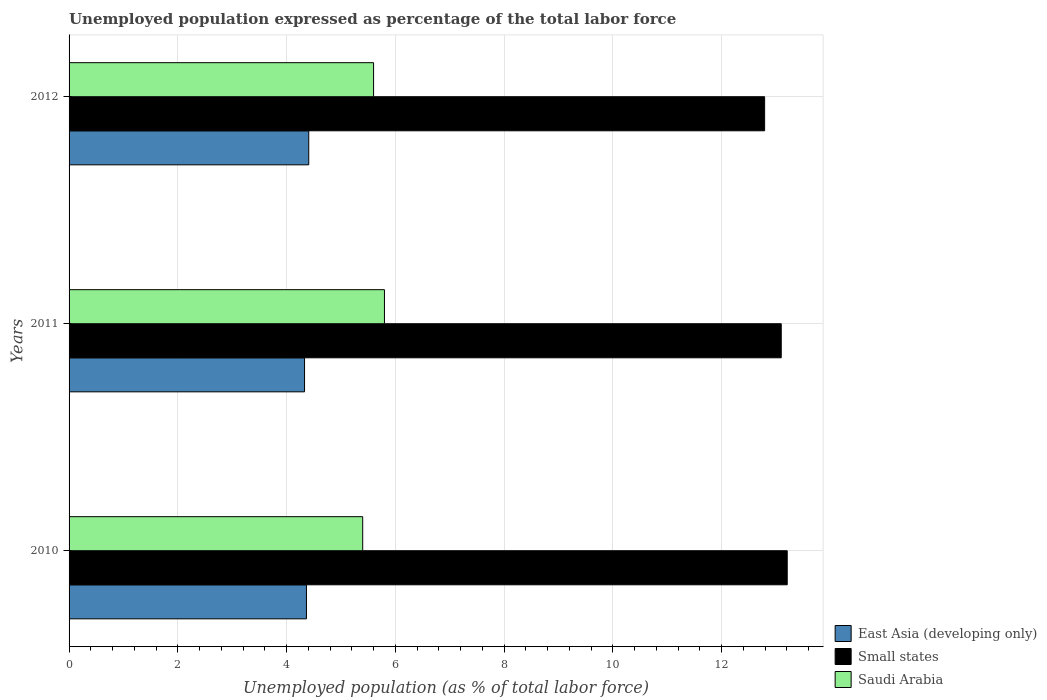How many different coloured bars are there?
Offer a terse response. 3. How many groups of bars are there?
Provide a short and direct response. 3. What is the label of the 2nd group of bars from the top?
Offer a very short reply. 2011. What is the unemployment in in Saudi Arabia in 2012?
Keep it short and to the point. 5.6. Across all years, what is the maximum unemployment in in Small states?
Make the answer very short. 13.21. Across all years, what is the minimum unemployment in in Small states?
Offer a very short reply. 12.79. In which year was the unemployment in in Saudi Arabia minimum?
Ensure brevity in your answer.  2010. What is the total unemployment in in Small states in the graph?
Offer a very short reply. 39.09. What is the difference between the unemployment in in Small states in 2010 and that in 2012?
Offer a terse response. 0.42. What is the difference between the unemployment in in East Asia (developing only) in 2010 and the unemployment in in Saudi Arabia in 2012?
Your response must be concise. -1.23. What is the average unemployment in in Saudi Arabia per year?
Offer a very short reply. 5.6. In the year 2012, what is the difference between the unemployment in in Small states and unemployment in in Saudi Arabia?
Your answer should be compact. 7.19. In how many years, is the unemployment in in East Asia (developing only) greater than 3.2 %?
Make the answer very short. 3. What is the ratio of the unemployment in in Saudi Arabia in 2010 to that in 2012?
Your answer should be very brief. 0.96. What is the difference between the highest and the second highest unemployment in in Small states?
Your response must be concise. 0.11. What is the difference between the highest and the lowest unemployment in in East Asia (developing only)?
Your answer should be very brief. 0.08. In how many years, is the unemployment in in Saudi Arabia greater than the average unemployment in in Saudi Arabia taken over all years?
Your answer should be compact. 1. Is the sum of the unemployment in in Saudi Arabia in 2010 and 2011 greater than the maximum unemployment in in Small states across all years?
Provide a succinct answer. No. What does the 1st bar from the top in 2010 represents?
Make the answer very short. Saudi Arabia. What does the 2nd bar from the bottom in 2011 represents?
Ensure brevity in your answer.  Small states. Is it the case that in every year, the sum of the unemployment in in Saudi Arabia and unemployment in in East Asia (developing only) is greater than the unemployment in in Small states?
Your answer should be compact. No. Are all the bars in the graph horizontal?
Offer a terse response. Yes. How many years are there in the graph?
Your response must be concise. 3. Are the values on the major ticks of X-axis written in scientific E-notation?
Your response must be concise. No. How many legend labels are there?
Ensure brevity in your answer.  3. How are the legend labels stacked?
Give a very brief answer. Vertical. What is the title of the graph?
Your response must be concise. Unemployed population expressed as percentage of the total labor force. Does "Low income" appear as one of the legend labels in the graph?
Offer a very short reply. No. What is the label or title of the X-axis?
Make the answer very short. Unemployed population (as % of total labor force). What is the Unemployed population (as % of total labor force) in East Asia (developing only) in 2010?
Offer a terse response. 4.37. What is the Unemployed population (as % of total labor force) in Small states in 2010?
Offer a very short reply. 13.21. What is the Unemployed population (as % of total labor force) in Saudi Arabia in 2010?
Your answer should be compact. 5.4. What is the Unemployed population (as % of total labor force) of East Asia (developing only) in 2011?
Keep it short and to the point. 4.33. What is the Unemployed population (as % of total labor force) in Small states in 2011?
Your answer should be very brief. 13.1. What is the Unemployed population (as % of total labor force) in Saudi Arabia in 2011?
Offer a very short reply. 5.8. What is the Unemployed population (as % of total labor force) in East Asia (developing only) in 2012?
Give a very brief answer. 4.41. What is the Unemployed population (as % of total labor force) of Small states in 2012?
Provide a short and direct response. 12.79. What is the Unemployed population (as % of total labor force) in Saudi Arabia in 2012?
Your answer should be very brief. 5.6. Across all years, what is the maximum Unemployed population (as % of total labor force) of East Asia (developing only)?
Keep it short and to the point. 4.41. Across all years, what is the maximum Unemployed population (as % of total labor force) in Small states?
Give a very brief answer. 13.21. Across all years, what is the maximum Unemployed population (as % of total labor force) in Saudi Arabia?
Offer a terse response. 5.8. Across all years, what is the minimum Unemployed population (as % of total labor force) in East Asia (developing only)?
Make the answer very short. 4.33. Across all years, what is the minimum Unemployed population (as % of total labor force) in Small states?
Offer a very short reply. 12.79. Across all years, what is the minimum Unemployed population (as % of total labor force) of Saudi Arabia?
Provide a short and direct response. 5.4. What is the total Unemployed population (as % of total labor force) of East Asia (developing only) in the graph?
Keep it short and to the point. 13.1. What is the total Unemployed population (as % of total labor force) of Small states in the graph?
Provide a succinct answer. 39.09. What is the total Unemployed population (as % of total labor force) in Saudi Arabia in the graph?
Offer a very short reply. 16.8. What is the difference between the Unemployed population (as % of total labor force) of East Asia (developing only) in 2010 and that in 2011?
Provide a short and direct response. 0.04. What is the difference between the Unemployed population (as % of total labor force) in Small states in 2010 and that in 2011?
Provide a succinct answer. 0.11. What is the difference between the Unemployed population (as % of total labor force) of East Asia (developing only) in 2010 and that in 2012?
Your answer should be very brief. -0.04. What is the difference between the Unemployed population (as % of total labor force) in Small states in 2010 and that in 2012?
Give a very brief answer. 0.42. What is the difference between the Unemployed population (as % of total labor force) in East Asia (developing only) in 2011 and that in 2012?
Your answer should be very brief. -0.08. What is the difference between the Unemployed population (as % of total labor force) of Small states in 2011 and that in 2012?
Your answer should be compact. 0.31. What is the difference between the Unemployed population (as % of total labor force) of East Asia (developing only) in 2010 and the Unemployed population (as % of total labor force) of Small states in 2011?
Offer a terse response. -8.73. What is the difference between the Unemployed population (as % of total labor force) in East Asia (developing only) in 2010 and the Unemployed population (as % of total labor force) in Saudi Arabia in 2011?
Keep it short and to the point. -1.43. What is the difference between the Unemployed population (as % of total labor force) in Small states in 2010 and the Unemployed population (as % of total labor force) in Saudi Arabia in 2011?
Ensure brevity in your answer.  7.41. What is the difference between the Unemployed population (as % of total labor force) in East Asia (developing only) in 2010 and the Unemployed population (as % of total labor force) in Small states in 2012?
Make the answer very short. -8.43. What is the difference between the Unemployed population (as % of total labor force) in East Asia (developing only) in 2010 and the Unemployed population (as % of total labor force) in Saudi Arabia in 2012?
Make the answer very short. -1.23. What is the difference between the Unemployed population (as % of total labor force) in Small states in 2010 and the Unemployed population (as % of total labor force) in Saudi Arabia in 2012?
Your response must be concise. 7.61. What is the difference between the Unemployed population (as % of total labor force) of East Asia (developing only) in 2011 and the Unemployed population (as % of total labor force) of Small states in 2012?
Your answer should be very brief. -8.46. What is the difference between the Unemployed population (as % of total labor force) in East Asia (developing only) in 2011 and the Unemployed population (as % of total labor force) in Saudi Arabia in 2012?
Make the answer very short. -1.27. What is the difference between the Unemployed population (as % of total labor force) of Small states in 2011 and the Unemployed population (as % of total labor force) of Saudi Arabia in 2012?
Provide a succinct answer. 7.5. What is the average Unemployed population (as % of total labor force) in East Asia (developing only) per year?
Ensure brevity in your answer.  4.37. What is the average Unemployed population (as % of total labor force) in Small states per year?
Provide a short and direct response. 13.03. In the year 2010, what is the difference between the Unemployed population (as % of total labor force) of East Asia (developing only) and Unemployed population (as % of total labor force) of Small states?
Provide a succinct answer. -8.84. In the year 2010, what is the difference between the Unemployed population (as % of total labor force) of East Asia (developing only) and Unemployed population (as % of total labor force) of Saudi Arabia?
Keep it short and to the point. -1.03. In the year 2010, what is the difference between the Unemployed population (as % of total labor force) in Small states and Unemployed population (as % of total labor force) in Saudi Arabia?
Provide a succinct answer. 7.81. In the year 2011, what is the difference between the Unemployed population (as % of total labor force) in East Asia (developing only) and Unemployed population (as % of total labor force) in Small states?
Ensure brevity in your answer.  -8.77. In the year 2011, what is the difference between the Unemployed population (as % of total labor force) in East Asia (developing only) and Unemployed population (as % of total labor force) in Saudi Arabia?
Your response must be concise. -1.47. In the year 2011, what is the difference between the Unemployed population (as % of total labor force) in Small states and Unemployed population (as % of total labor force) in Saudi Arabia?
Keep it short and to the point. 7.3. In the year 2012, what is the difference between the Unemployed population (as % of total labor force) in East Asia (developing only) and Unemployed population (as % of total labor force) in Small states?
Give a very brief answer. -8.38. In the year 2012, what is the difference between the Unemployed population (as % of total labor force) in East Asia (developing only) and Unemployed population (as % of total labor force) in Saudi Arabia?
Ensure brevity in your answer.  -1.19. In the year 2012, what is the difference between the Unemployed population (as % of total labor force) of Small states and Unemployed population (as % of total labor force) of Saudi Arabia?
Provide a short and direct response. 7.19. What is the ratio of the Unemployed population (as % of total labor force) in Small states in 2010 to that in 2011?
Your response must be concise. 1.01. What is the ratio of the Unemployed population (as % of total labor force) of East Asia (developing only) in 2010 to that in 2012?
Make the answer very short. 0.99. What is the ratio of the Unemployed population (as % of total labor force) in Small states in 2010 to that in 2012?
Offer a very short reply. 1.03. What is the ratio of the Unemployed population (as % of total labor force) in East Asia (developing only) in 2011 to that in 2012?
Ensure brevity in your answer.  0.98. What is the ratio of the Unemployed population (as % of total labor force) of Small states in 2011 to that in 2012?
Give a very brief answer. 1.02. What is the ratio of the Unemployed population (as % of total labor force) of Saudi Arabia in 2011 to that in 2012?
Provide a short and direct response. 1.04. What is the difference between the highest and the second highest Unemployed population (as % of total labor force) in East Asia (developing only)?
Ensure brevity in your answer.  0.04. What is the difference between the highest and the second highest Unemployed population (as % of total labor force) in Small states?
Offer a terse response. 0.11. What is the difference between the highest and the second highest Unemployed population (as % of total labor force) of Saudi Arabia?
Provide a short and direct response. 0.2. What is the difference between the highest and the lowest Unemployed population (as % of total labor force) of East Asia (developing only)?
Give a very brief answer. 0.08. What is the difference between the highest and the lowest Unemployed population (as % of total labor force) of Small states?
Make the answer very short. 0.42. What is the difference between the highest and the lowest Unemployed population (as % of total labor force) in Saudi Arabia?
Ensure brevity in your answer.  0.4. 